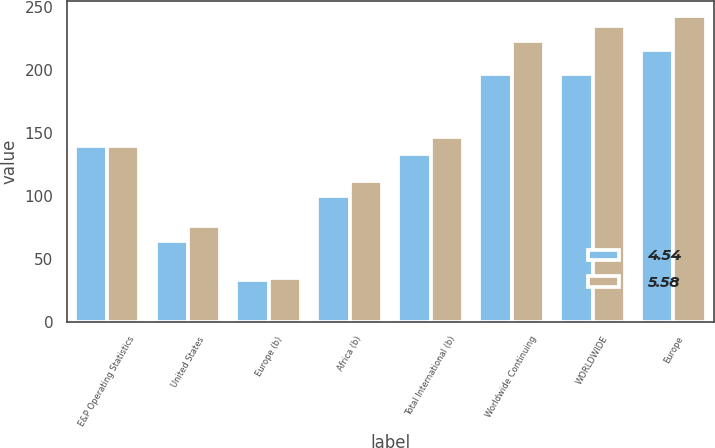<chart> <loc_0><loc_0><loc_500><loc_500><stacked_bar_chart><ecel><fcel>E&P Operating Statistics<fcel>United States<fcel>Europe (b)<fcel>Africa (b)<fcel>Total International (b)<fcel>Worldwide Continuing<fcel>WORLDWIDE<fcel>Europe<nl><fcel>4.54<fcel>140<fcel>64<fcel>33<fcel>100<fcel>133<fcel>197<fcel>197<fcel>216<nl><fcel>5.58<fcel>140<fcel>76<fcel>35<fcel>112<fcel>147<fcel>223<fcel>235<fcel>243<nl></chart> 